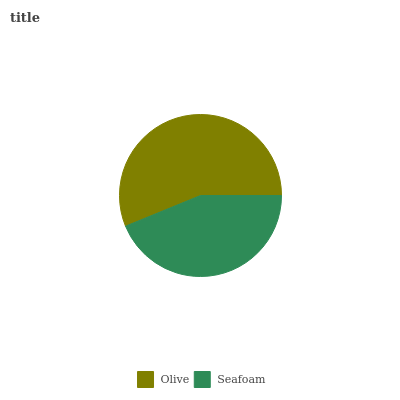Is Seafoam the minimum?
Answer yes or no. Yes. Is Olive the maximum?
Answer yes or no. Yes. Is Seafoam the maximum?
Answer yes or no. No. Is Olive greater than Seafoam?
Answer yes or no. Yes. Is Seafoam less than Olive?
Answer yes or no. Yes. Is Seafoam greater than Olive?
Answer yes or no. No. Is Olive less than Seafoam?
Answer yes or no. No. Is Olive the high median?
Answer yes or no. Yes. Is Seafoam the low median?
Answer yes or no. Yes. Is Seafoam the high median?
Answer yes or no. No. Is Olive the low median?
Answer yes or no. No. 